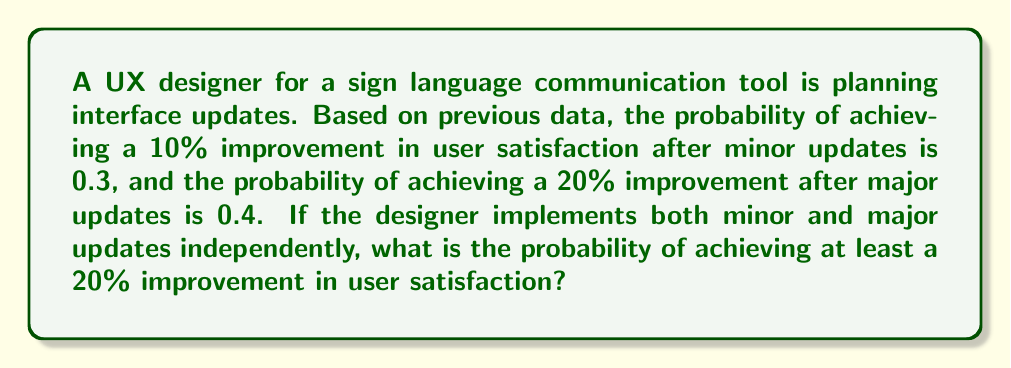Can you solve this math problem? Let's approach this step-by-step:

1) Define events:
   A: 10% improvement (minor update)
   B: 20% improvement (major update)

2) Given probabilities:
   P(A) = 0.3
   P(B) = 0.4

3) We want to find the probability of achieving at least a 20% improvement. This can happen in two ways:
   - Only the major update succeeds (B occurs)
   - Both updates succeed (A and B occur)

4) Assuming independence, the probability of both updates succeeding is:
   P(A and B) = P(A) × P(B) = 0.3 × 0.4 = 0.12

5) The probability of at least a 20% improvement is:
   P(at least 20% improvement) = P(B) + P(A and B) - P(B and A and B)
   
   This is because we need to add the probability of B occurring alone and the probability of both A and B occurring, but we need to subtract the overlap (when B occurs in both cases) to avoid double counting.

6) Simplifying:
   P(at least 20% improvement) = P(B) + P(A and B) - P(B)P(A and B)
   = 0.4 + 0.12 - (0.4 × 0.12)
   = 0.52 - 0.048
   = 0.472

Therefore, the probability of achieving at least a 20% improvement in user satisfaction is 0.472 or 47.2%.
Answer: 0.472 